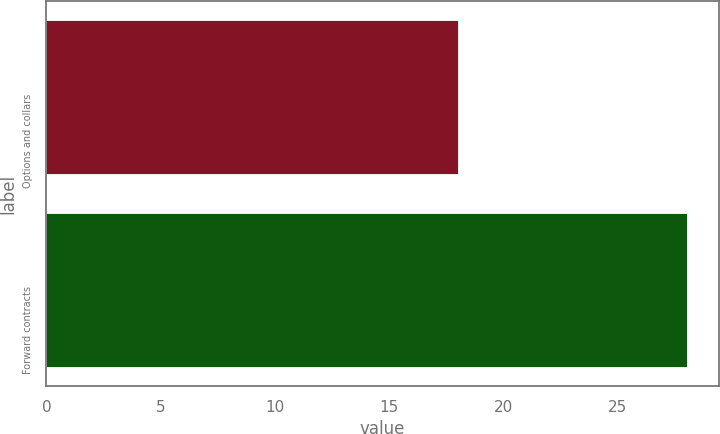Convert chart to OTSL. <chart><loc_0><loc_0><loc_500><loc_500><bar_chart><fcel>Options and collars<fcel>Forward contracts<nl><fcel>18<fcel>28<nl></chart> 